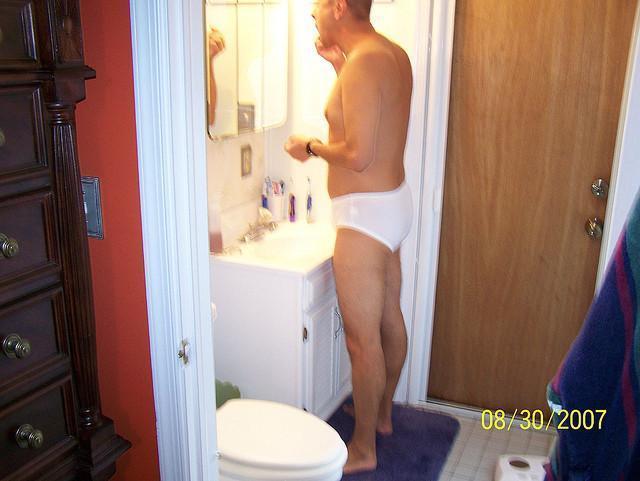How many ski poles are there?
Give a very brief answer. 0. 